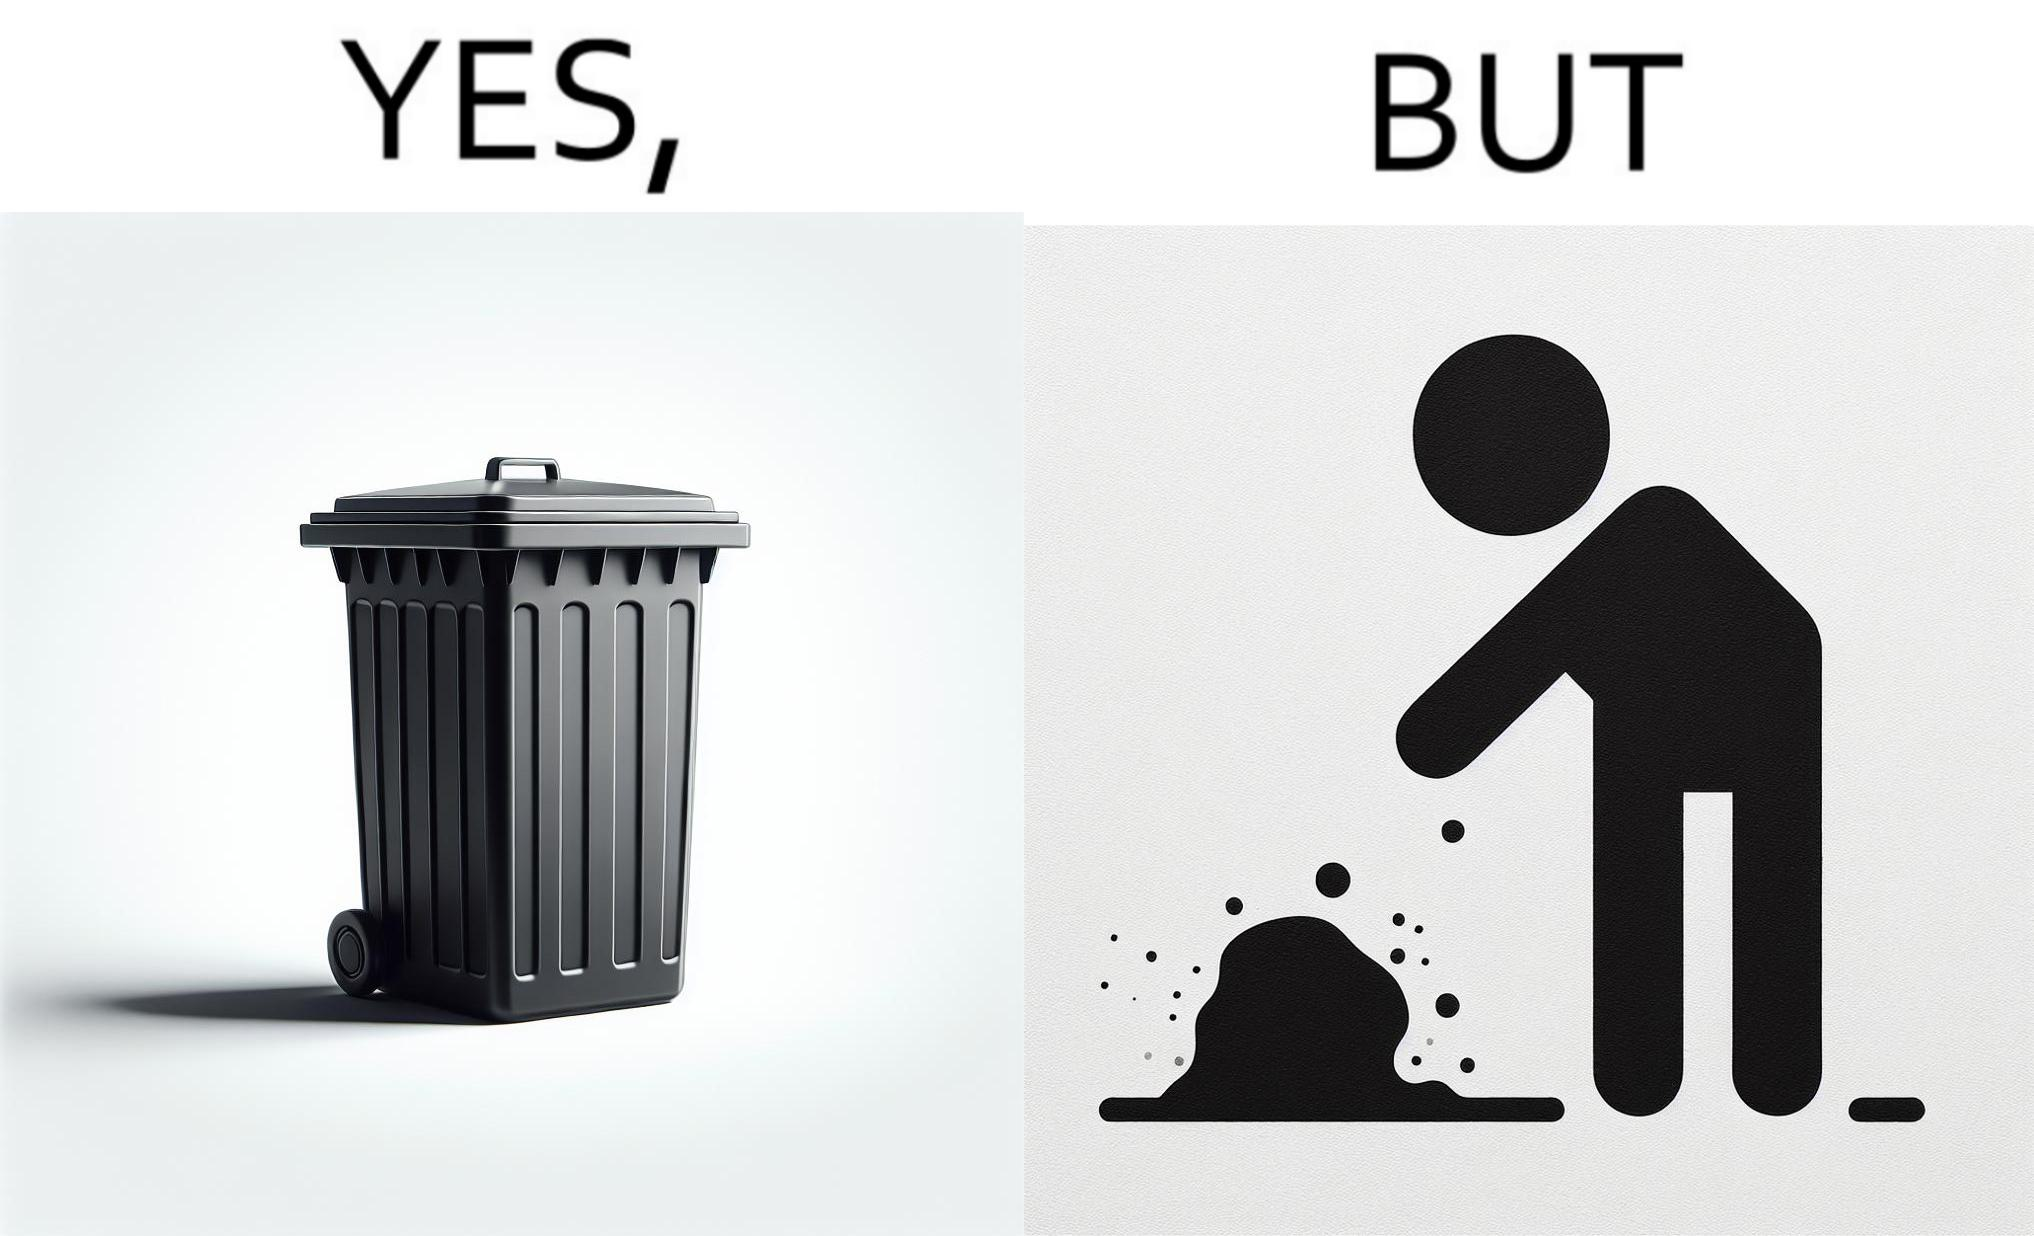What is shown in this image? The images are ironic because even though garbage bins are provided for humans to dispose waste, by habit humans still choose to make surroundings dirty by disposing garbage improperly 